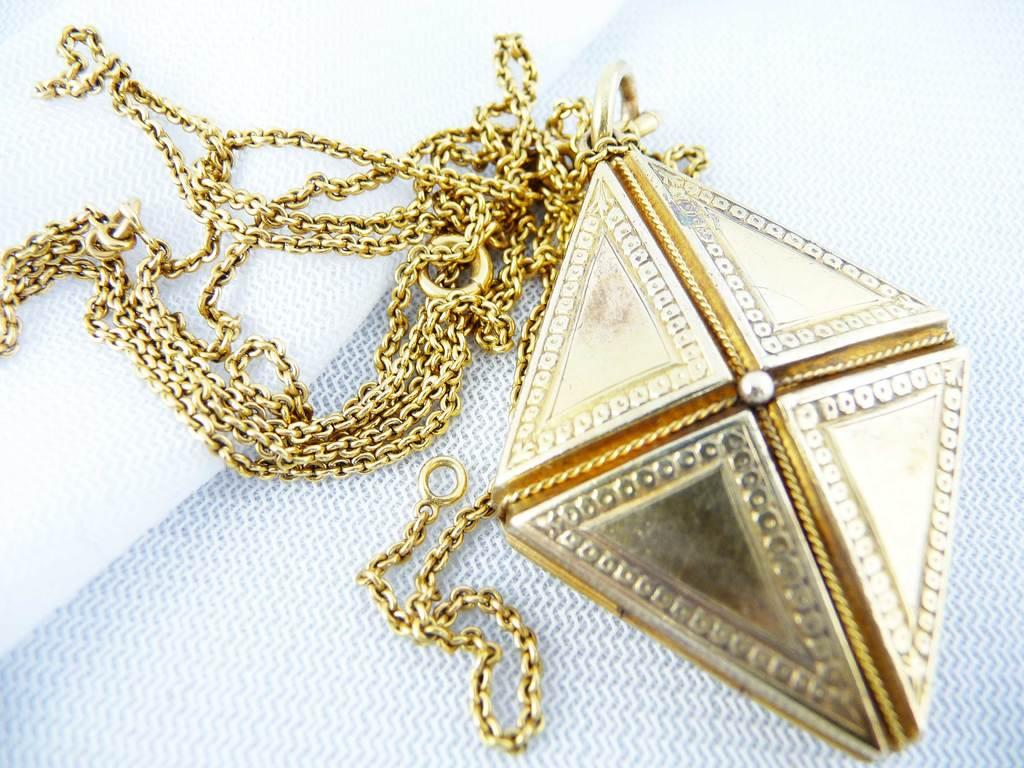What is the main object in the image? There is a locket in the image. What material is used for the chains of the locket? The locket has golden chains. What color is the background of the image? The background of the image is white. What is the mass of the locket in the image? The mass of the locket cannot be determined from the image alone, as it does not provide any information about the size or weight of the locket. 